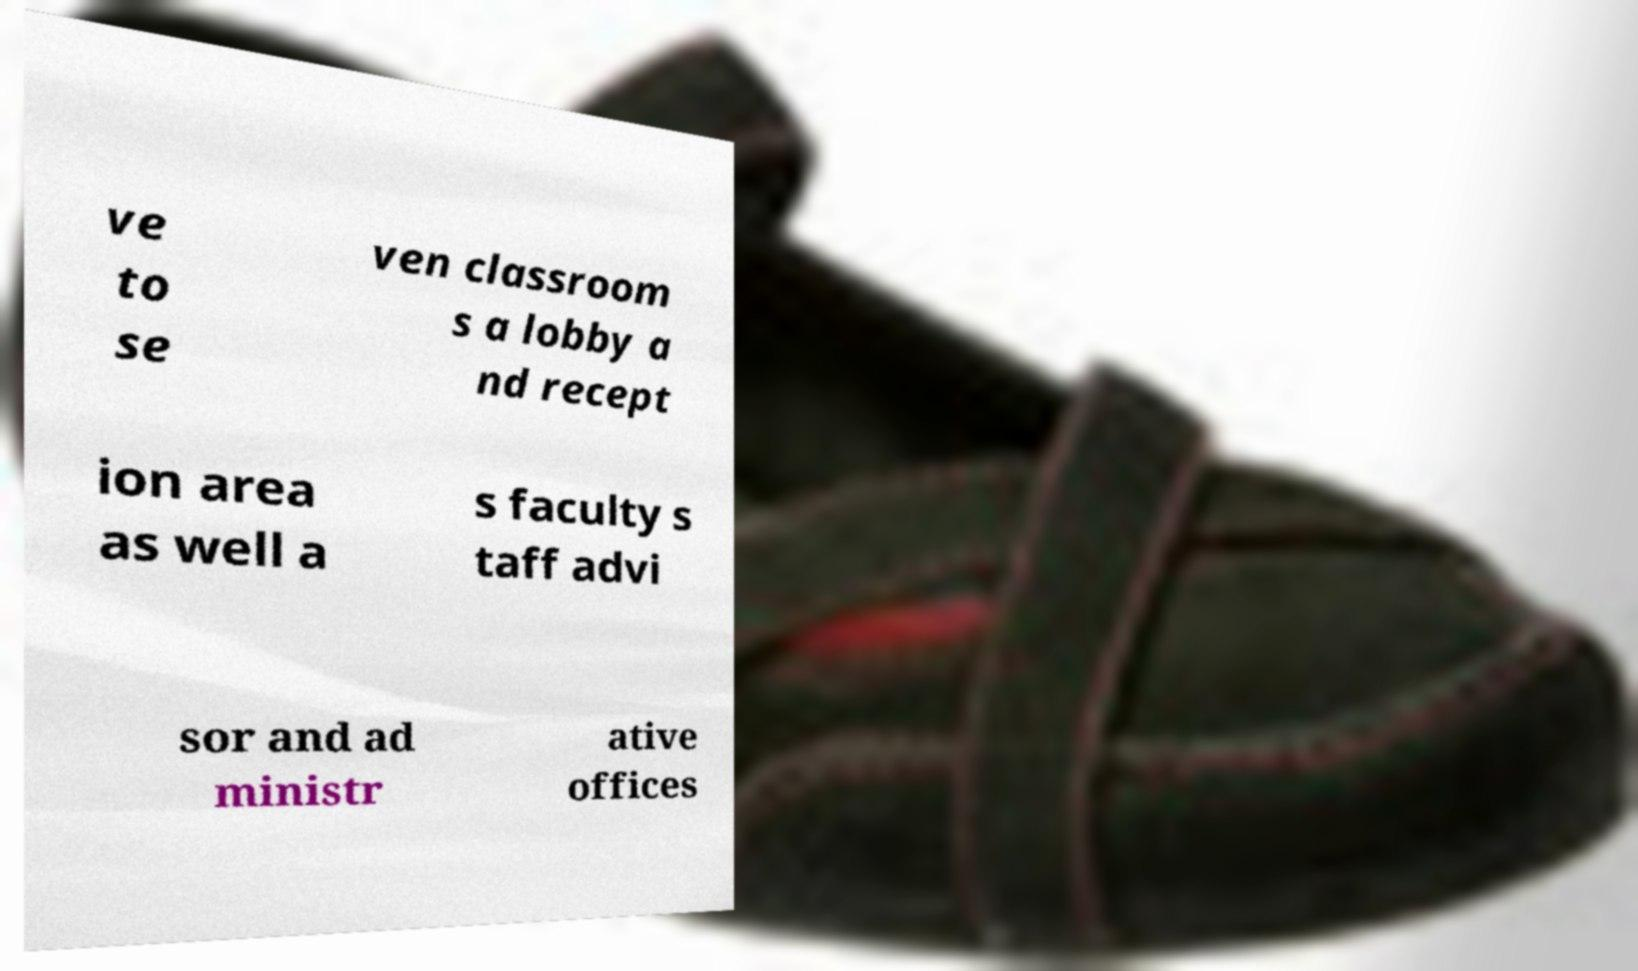Can you read and provide the text displayed in the image?This photo seems to have some interesting text. Can you extract and type it out for me? ve to se ven classroom s a lobby a nd recept ion area as well a s faculty s taff advi sor and ad ministr ative offices 